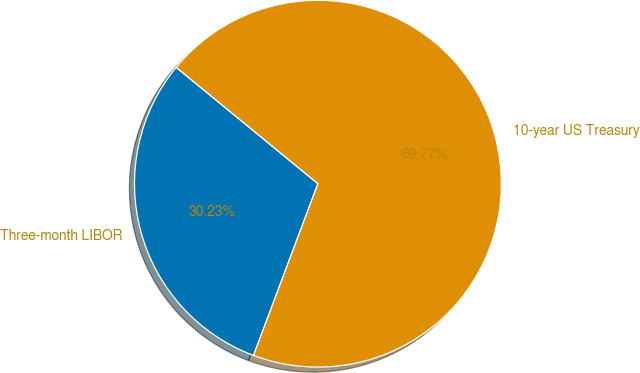Convert chart to OTSL. <chart><loc_0><loc_0><loc_500><loc_500><pie_chart><fcel>Three-month LIBOR<fcel>10-year US Treasury<nl><fcel>30.23%<fcel>69.77%<nl></chart> 